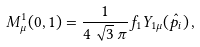Convert formula to latex. <formula><loc_0><loc_0><loc_500><loc_500>M _ { \mu } ^ { 1 } ( 0 , 1 ) = \frac { 1 } { 4 \, \sqrt { 3 } \, \pi } f _ { 1 } Y _ { 1 \mu } ( \hat { p _ { i } } ) \, ,</formula> 